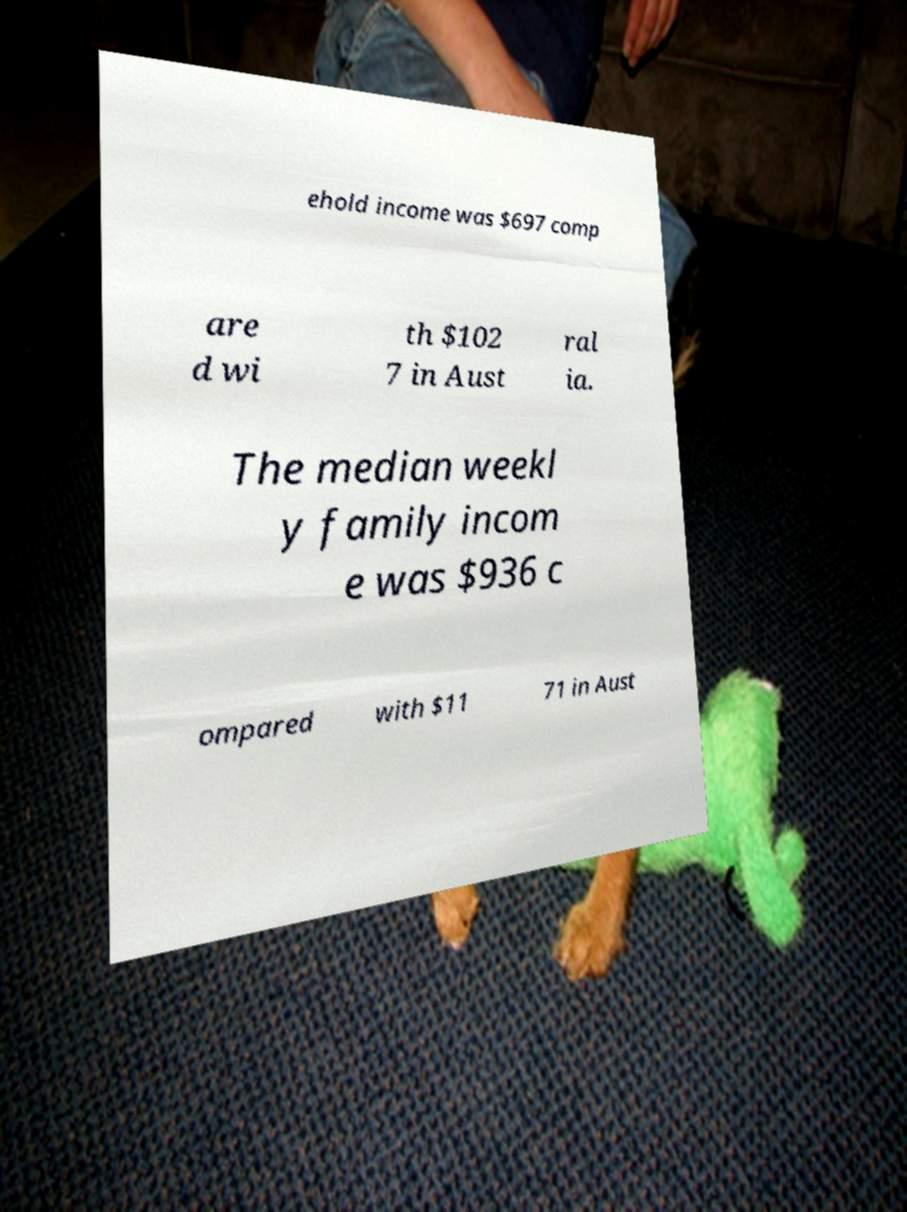For documentation purposes, I need the text within this image transcribed. Could you provide that? ehold income was $697 comp are d wi th $102 7 in Aust ral ia. The median weekl y family incom e was $936 c ompared with $11 71 in Aust 